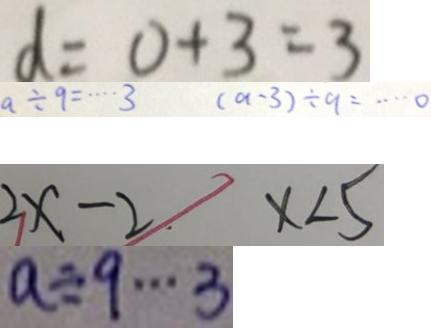<formula> <loc_0><loc_0><loc_500><loc_500>d = 0 + 3 = 3 
 a \div 9 \cdots 3 ( a - 3 ) \div 9 = \cdots 0 
 2 x - 2 x < 5 
 a \div 9 \cdots 3</formula> 